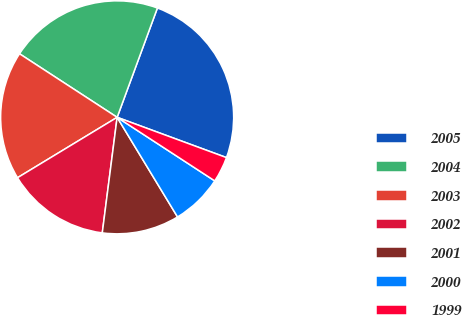Convert chart to OTSL. <chart><loc_0><loc_0><loc_500><loc_500><pie_chart><fcel>2005<fcel>2004<fcel>2003<fcel>2002<fcel>2001<fcel>2000<fcel>1999<nl><fcel>25.0%<fcel>21.43%<fcel>17.86%<fcel>14.29%<fcel>10.71%<fcel>7.14%<fcel>3.57%<nl></chart> 